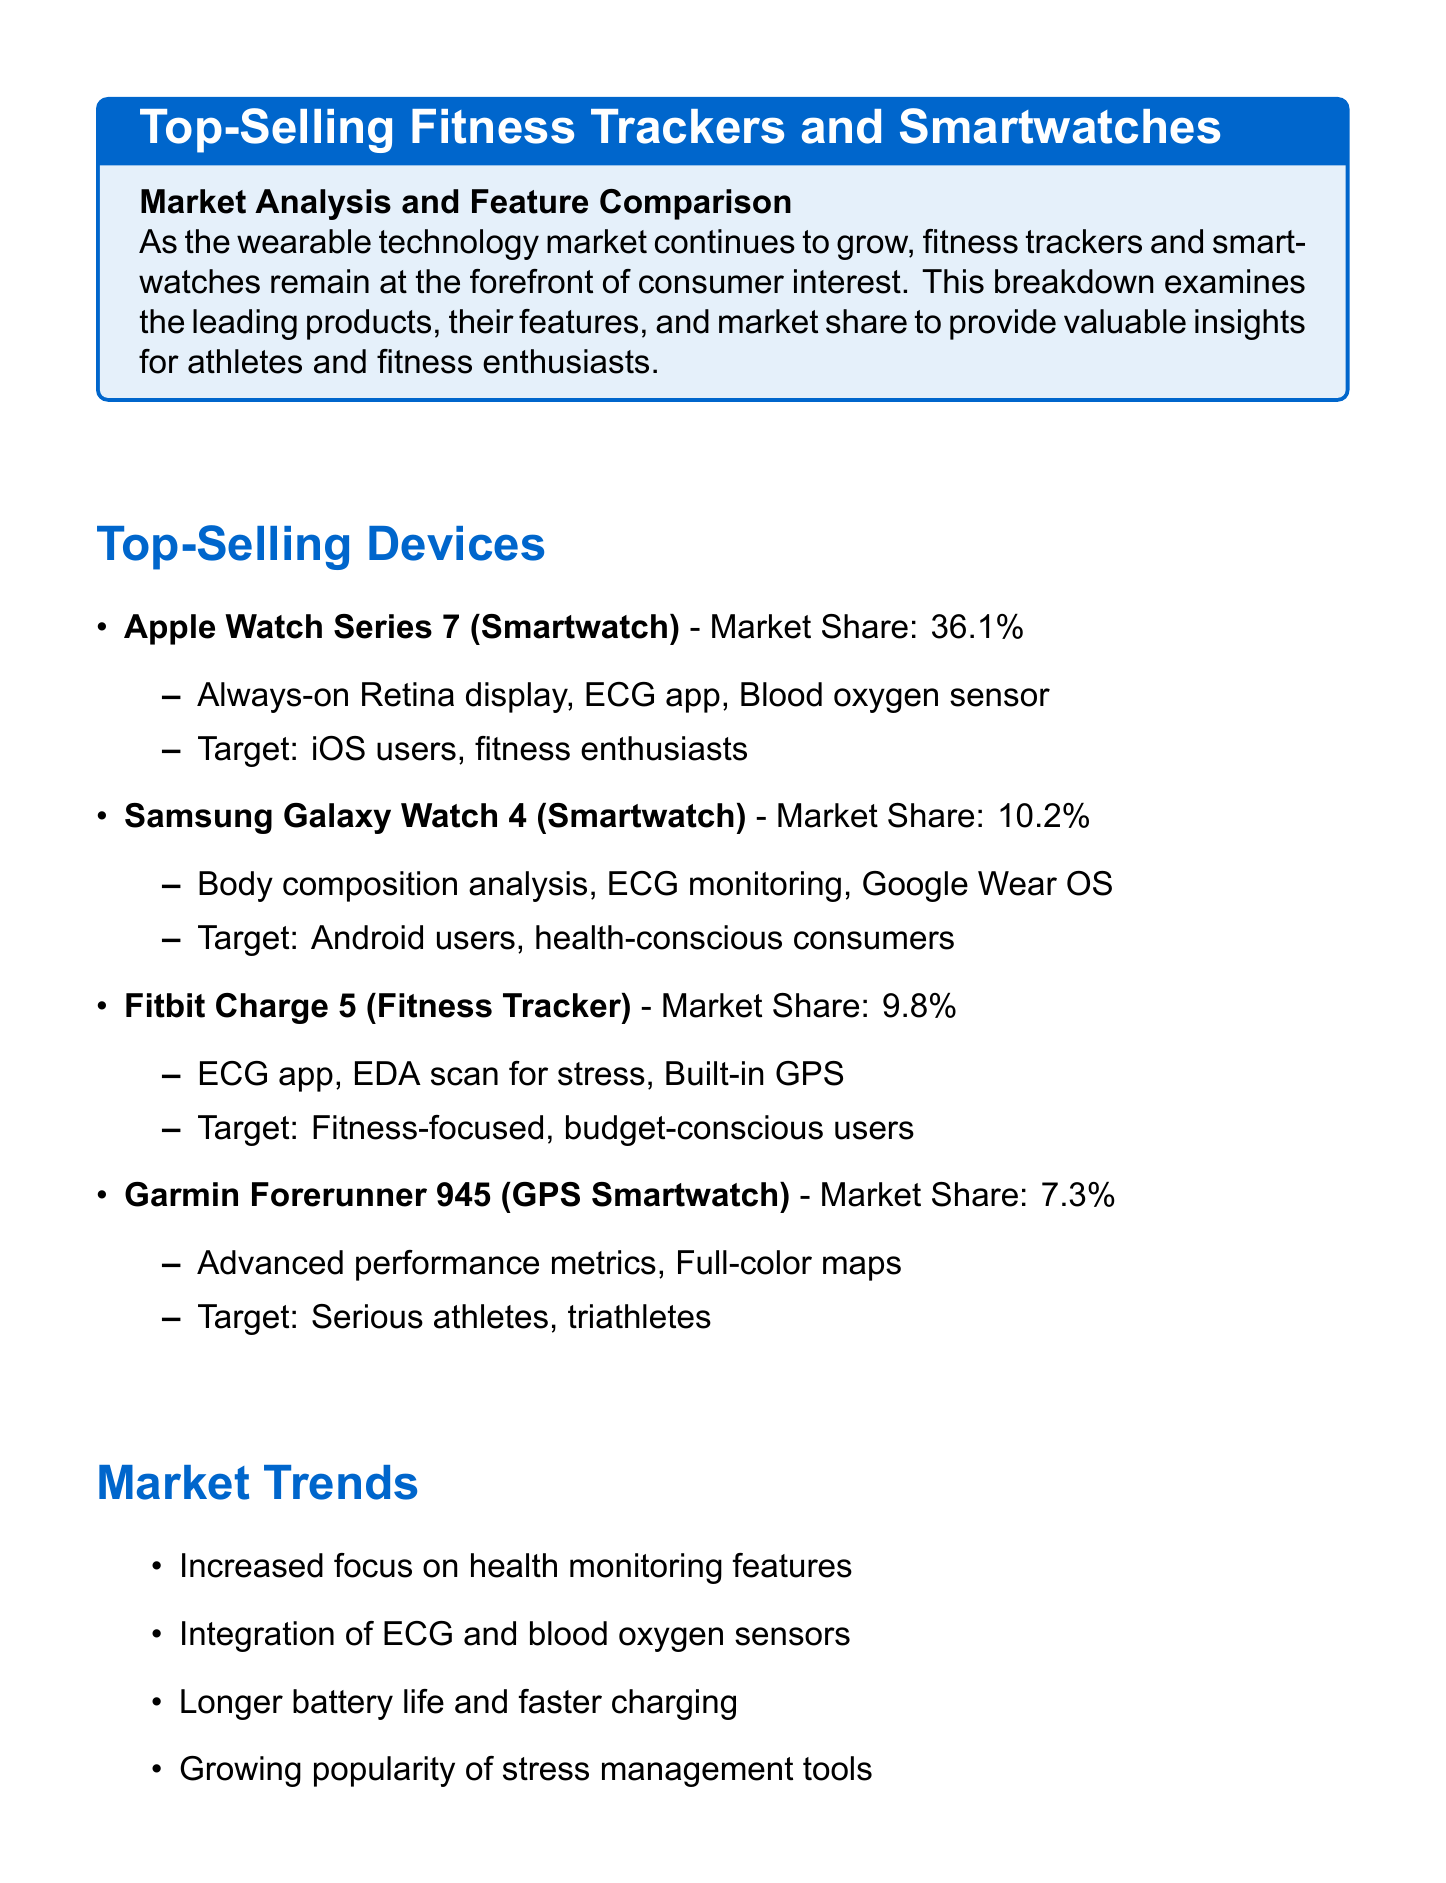What is the market share of the Apple Watch Series 7? The market share is provided in the document, indicating it is 36.1%.
Answer: 36.1% Which device is targeted at serious athletes? The document lists the Garmin Forerunner 945 as the device targeted at serious athletes and triathletes.
Answer: Garmin Forerunner 945 What emerging technology is mentioned for the future outlook? The document states several emerging technologies, one being non-invasive glucose monitoring.
Answer: Non-invasive glucose monitoring What is the market projection value for fitness trackers and smartwatches by 2028? The document specifies that the market is expected to reach $114 billion by 2028.
Answer: $114 billion What feature does the Samsung Galaxy Watch 4 have that focuses on health? The document lists body composition analysis as a key feature of the Samsung Galaxy Watch 4.
Answer: Body composition analysis What percentage of the market share does Fitbit Charge 5 hold? The document states that Fitbit Charge 5 has a market share of 9.8%.
Answer: 9.8% What consumer preference is highlighted in the document? One preference mentioned is the demand for accurate fitness tracking as outlined in the document.
Answer: Accurate fitness tracking Which smartwatch integrates Google Wear OS? The document identifies the Samsung Galaxy Watch 4 as the smartwatch that incorporates Google Wear OS.
Answer: Samsung Galaxy Watch 4 